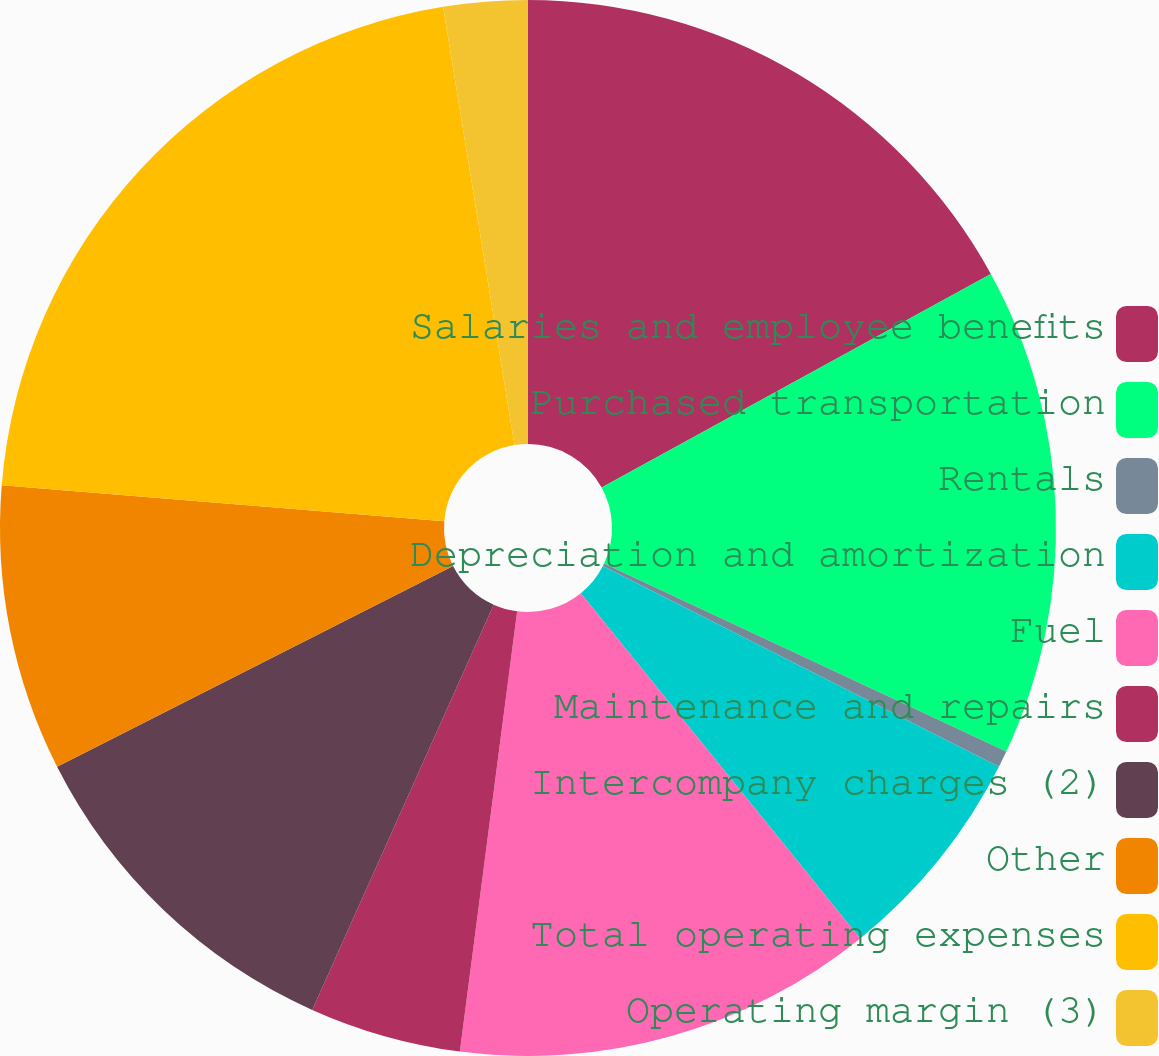Convert chart to OTSL. <chart><loc_0><loc_0><loc_500><loc_500><pie_chart><fcel>Salaries and employee benefits<fcel>Purchased transportation<fcel>Rentals<fcel>Depreciation and amortization<fcel>Fuel<fcel>Maintenance and repairs<fcel>Intercompany charges (2)<fcel>Other<fcel>Total operating expenses<fcel>Operating margin (3)<nl><fcel>17.01%<fcel>14.95%<fcel>0.51%<fcel>6.7%<fcel>12.89%<fcel>4.64%<fcel>10.83%<fcel>8.76%<fcel>21.14%<fcel>2.57%<nl></chart> 